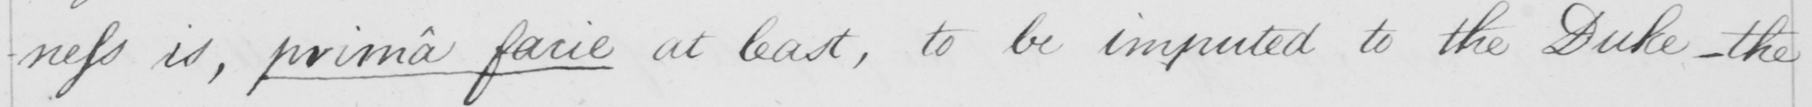Can you read and transcribe this handwriting? -ness is ,  prima facie  at least , to be imputed to the Duke  _  the 